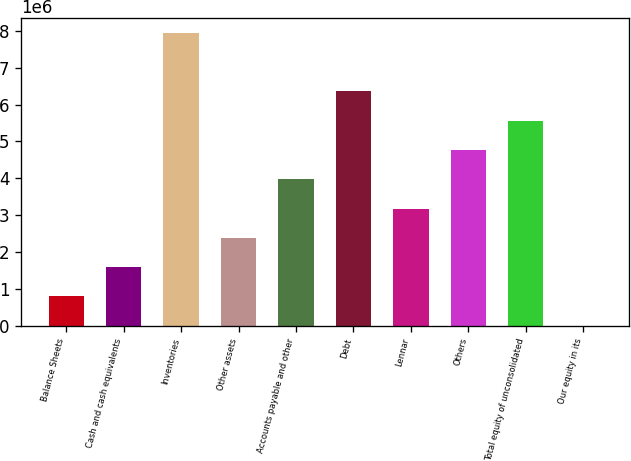Convert chart. <chart><loc_0><loc_0><loc_500><loc_500><bar_chart><fcel>Balance Sheets<fcel>Cash and cash equivalents<fcel>Inventories<fcel>Other assets<fcel>Accounts payable and other<fcel>Debt<fcel>Lennar<fcel>Others<fcel>Total equity of unconsolidated<fcel>Our equity in its<nl><fcel>794214<fcel>1.58839e+06<fcel>7.94184e+06<fcel>2.38257e+06<fcel>3.97093e+06<fcel>6.35347e+06<fcel>3.17675e+06<fcel>4.76511e+06<fcel>5.55929e+06<fcel>34<nl></chart> 